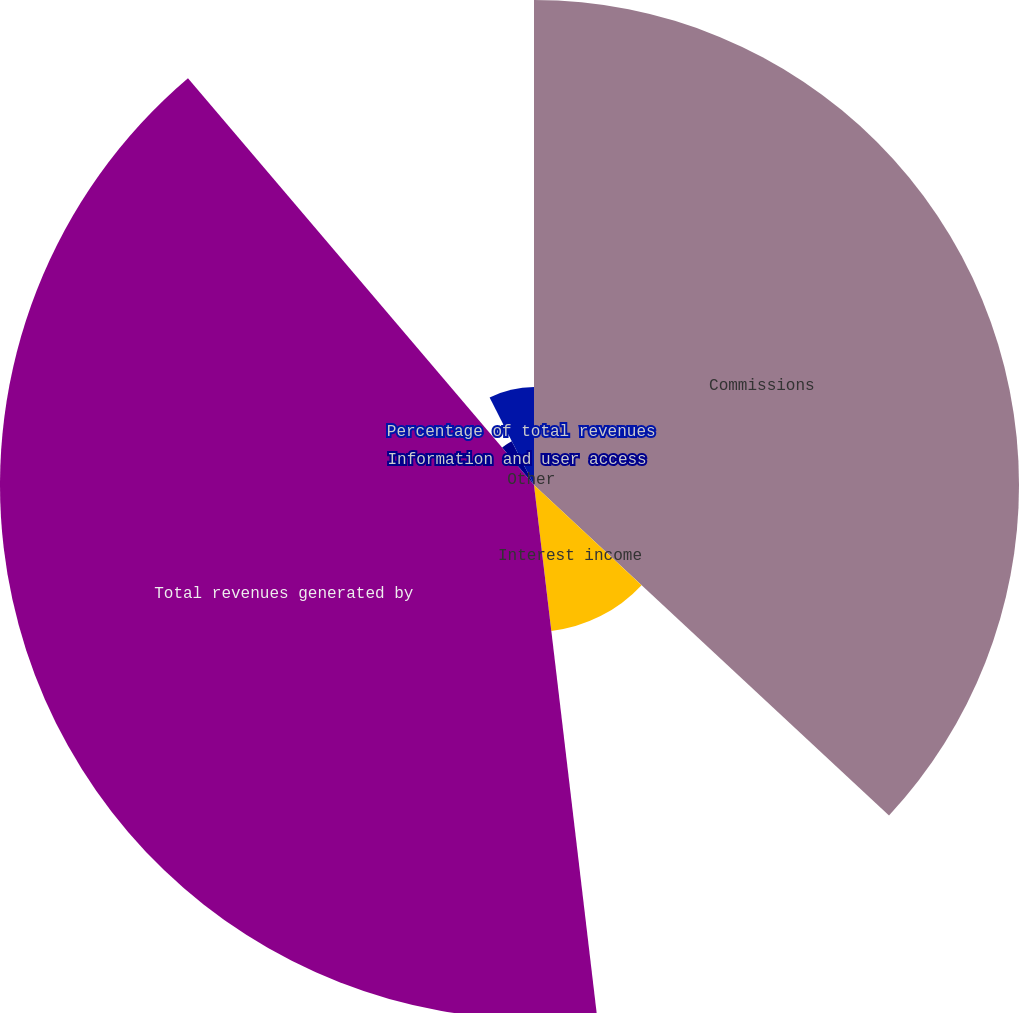Convert chart to OTSL. <chart><loc_0><loc_0><loc_500><loc_500><pie_chart><fcel>Commissions<fcel>Interest income<fcel>Total revenues generated by<fcel>Information and user access<fcel>Other<fcel>Percentage of total revenues<nl><fcel>36.93%<fcel>11.19%<fcel>40.66%<fcel>3.74%<fcel>0.01%<fcel>7.47%<nl></chart> 